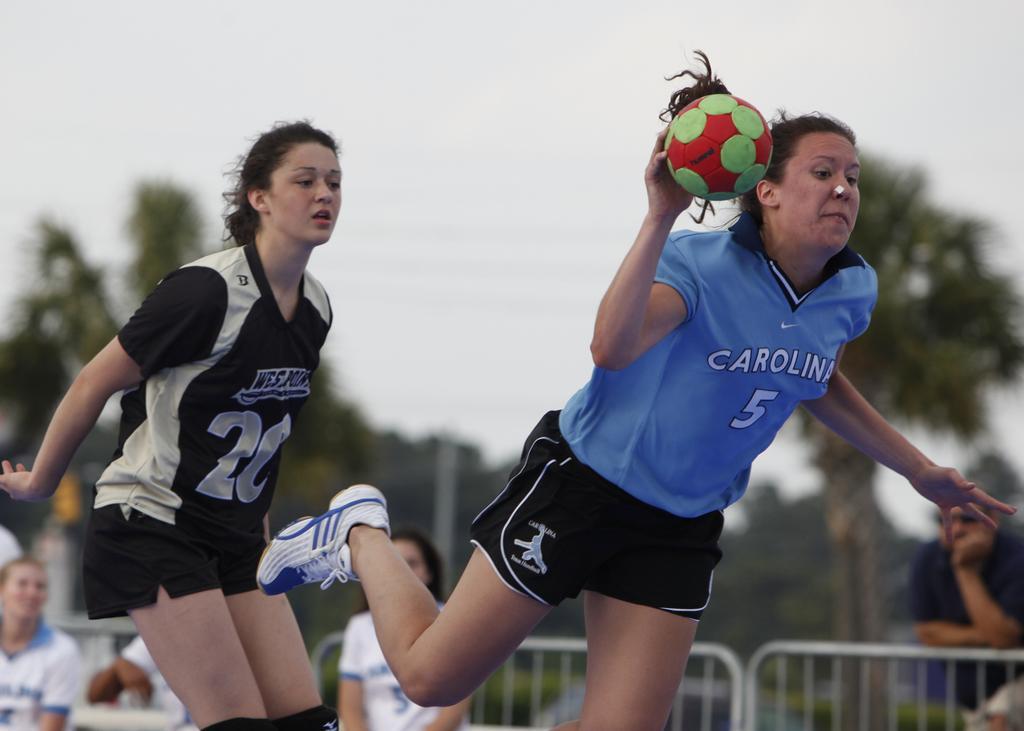Please provide a concise description of this image. In this picture there are two ladies. Left side lady is wearing a black color t-shirt. And the side lady she is wearing a blue t-shirt and a black short. In her hand there is a ball. She is throwing a ball. In the back of them there are some people sitting. There is a railing. And in the background there is a tree and a sky. 